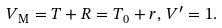Convert formula to latex. <formula><loc_0><loc_0><loc_500><loc_500>V _ { \text {M} } = T + R = T _ { 0 } + r , \, V ^ { \prime } = 1 .</formula> 